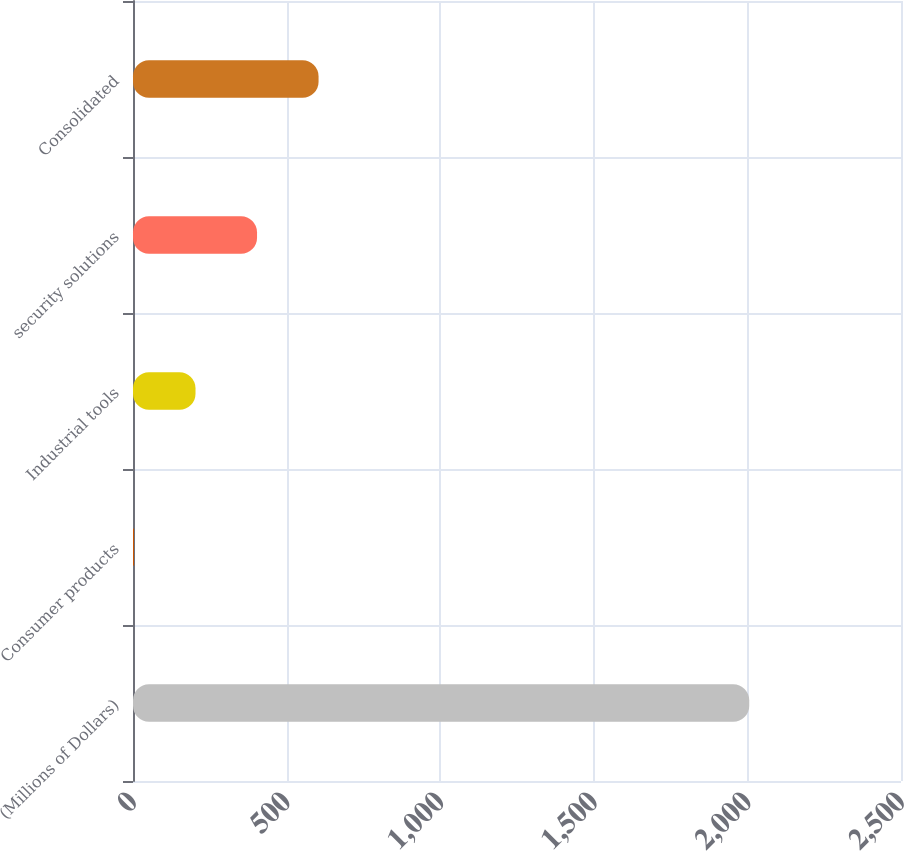<chart> <loc_0><loc_0><loc_500><loc_500><bar_chart><fcel>(Millions of Dollars)<fcel>Consumer products<fcel>Industrial tools<fcel>security solutions<fcel>Consolidated<nl><fcel>2006<fcel>3.2<fcel>203.48<fcel>403.76<fcel>604.04<nl></chart> 